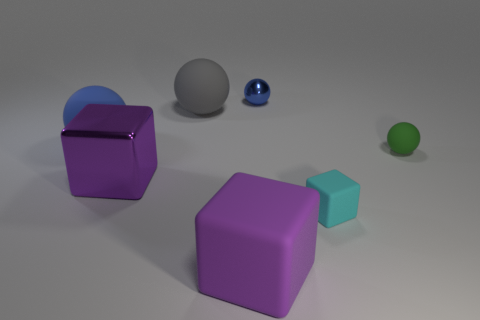What can you infer about the lighting in this scene? The lighting in the scene suggests there is a single diffuse light source, possibly overhead, which creates soft shadows below the objects, indicating the scene is likely indoors or in a controlled lighting environment. 